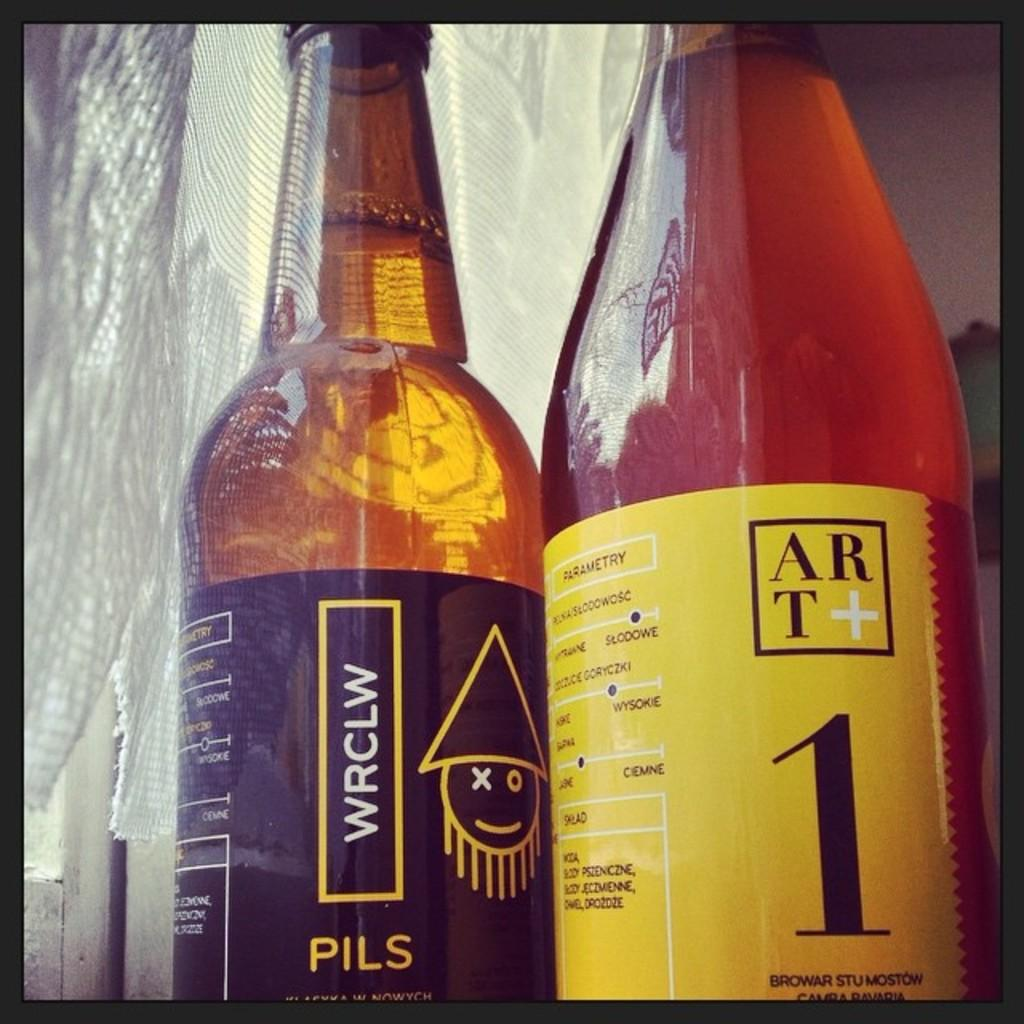<image>
Offer a succinct explanation of the picture presented. A close up of two bottles of PILS lager, one has a black label the other, yellow. 